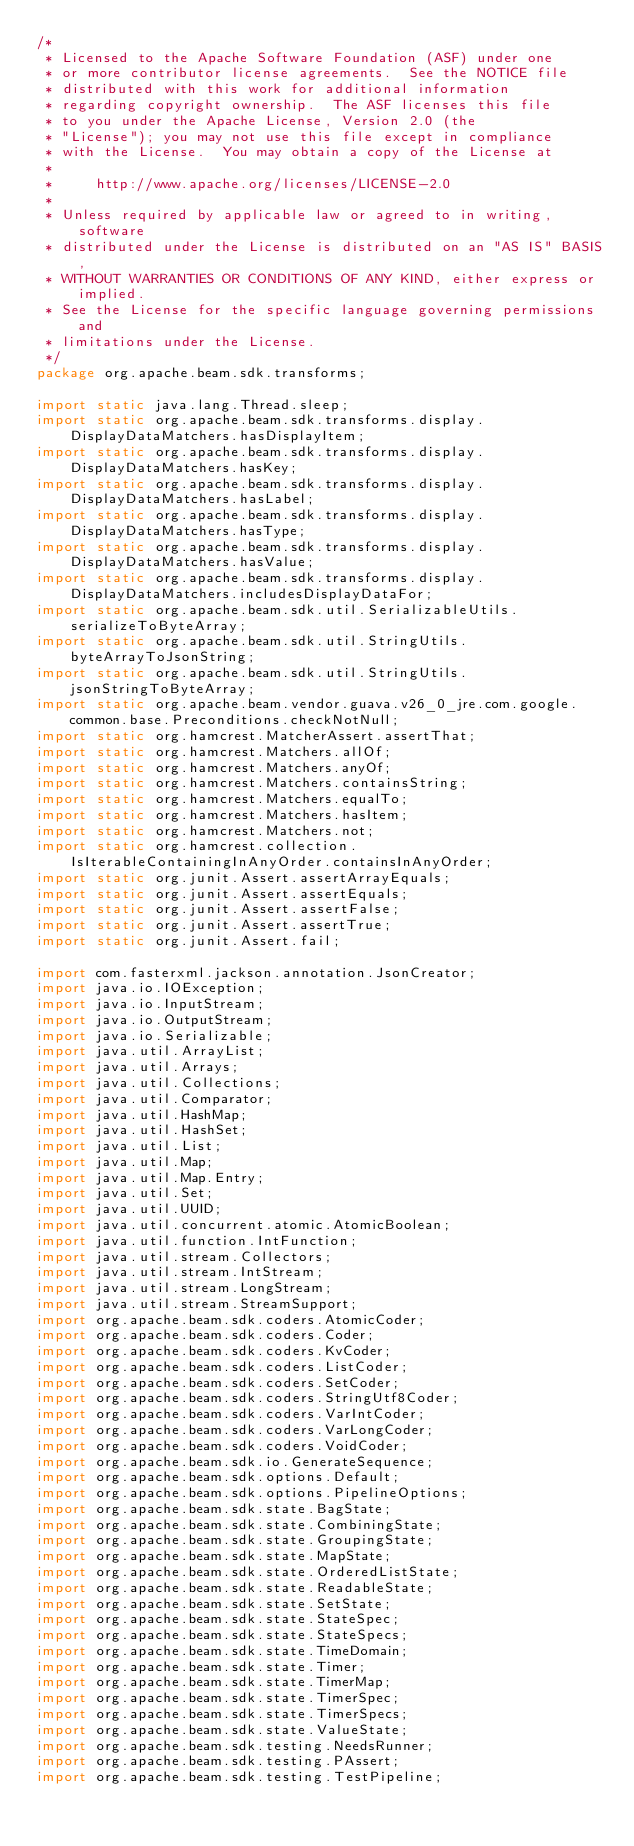Convert code to text. <code><loc_0><loc_0><loc_500><loc_500><_Java_>/*
 * Licensed to the Apache Software Foundation (ASF) under one
 * or more contributor license agreements.  See the NOTICE file
 * distributed with this work for additional information
 * regarding copyright ownership.  The ASF licenses this file
 * to you under the Apache License, Version 2.0 (the
 * "License"); you may not use this file except in compliance
 * with the License.  You may obtain a copy of the License at
 *
 *     http://www.apache.org/licenses/LICENSE-2.0
 *
 * Unless required by applicable law or agreed to in writing, software
 * distributed under the License is distributed on an "AS IS" BASIS,
 * WITHOUT WARRANTIES OR CONDITIONS OF ANY KIND, either express or implied.
 * See the License for the specific language governing permissions and
 * limitations under the License.
 */
package org.apache.beam.sdk.transforms;

import static java.lang.Thread.sleep;
import static org.apache.beam.sdk.transforms.display.DisplayDataMatchers.hasDisplayItem;
import static org.apache.beam.sdk.transforms.display.DisplayDataMatchers.hasKey;
import static org.apache.beam.sdk.transforms.display.DisplayDataMatchers.hasLabel;
import static org.apache.beam.sdk.transforms.display.DisplayDataMatchers.hasType;
import static org.apache.beam.sdk.transforms.display.DisplayDataMatchers.hasValue;
import static org.apache.beam.sdk.transforms.display.DisplayDataMatchers.includesDisplayDataFor;
import static org.apache.beam.sdk.util.SerializableUtils.serializeToByteArray;
import static org.apache.beam.sdk.util.StringUtils.byteArrayToJsonString;
import static org.apache.beam.sdk.util.StringUtils.jsonStringToByteArray;
import static org.apache.beam.vendor.guava.v26_0_jre.com.google.common.base.Preconditions.checkNotNull;
import static org.hamcrest.MatcherAssert.assertThat;
import static org.hamcrest.Matchers.allOf;
import static org.hamcrest.Matchers.anyOf;
import static org.hamcrest.Matchers.containsString;
import static org.hamcrest.Matchers.equalTo;
import static org.hamcrest.Matchers.hasItem;
import static org.hamcrest.Matchers.not;
import static org.hamcrest.collection.IsIterableContainingInAnyOrder.containsInAnyOrder;
import static org.junit.Assert.assertArrayEquals;
import static org.junit.Assert.assertEquals;
import static org.junit.Assert.assertFalse;
import static org.junit.Assert.assertTrue;
import static org.junit.Assert.fail;

import com.fasterxml.jackson.annotation.JsonCreator;
import java.io.IOException;
import java.io.InputStream;
import java.io.OutputStream;
import java.io.Serializable;
import java.util.ArrayList;
import java.util.Arrays;
import java.util.Collections;
import java.util.Comparator;
import java.util.HashMap;
import java.util.HashSet;
import java.util.List;
import java.util.Map;
import java.util.Map.Entry;
import java.util.Set;
import java.util.UUID;
import java.util.concurrent.atomic.AtomicBoolean;
import java.util.function.IntFunction;
import java.util.stream.Collectors;
import java.util.stream.IntStream;
import java.util.stream.LongStream;
import java.util.stream.StreamSupport;
import org.apache.beam.sdk.coders.AtomicCoder;
import org.apache.beam.sdk.coders.Coder;
import org.apache.beam.sdk.coders.KvCoder;
import org.apache.beam.sdk.coders.ListCoder;
import org.apache.beam.sdk.coders.SetCoder;
import org.apache.beam.sdk.coders.StringUtf8Coder;
import org.apache.beam.sdk.coders.VarIntCoder;
import org.apache.beam.sdk.coders.VarLongCoder;
import org.apache.beam.sdk.coders.VoidCoder;
import org.apache.beam.sdk.io.GenerateSequence;
import org.apache.beam.sdk.options.Default;
import org.apache.beam.sdk.options.PipelineOptions;
import org.apache.beam.sdk.state.BagState;
import org.apache.beam.sdk.state.CombiningState;
import org.apache.beam.sdk.state.GroupingState;
import org.apache.beam.sdk.state.MapState;
import org.apache.beam.sdk.state.OrderedListState;
import org.apache.beam.sdk.state.ReadableState;
import org.apache.beam.sdk.state.SetState;
import org.apache.beam.sdk.state.StateSpec;
import org.apache.beam.sdk.state.StateSpecs;
import org.apache.beam.sdk.state.TimeDomain;
import org.apache.beam.sdk.state.Timer;
import org.apache.beam.sdk.state.TimerMap;
import org.apache.beam.sdk.state.TimerSpec;
import org.apache.beam.sdk.state.TimerSpecs;
import org.apache.beam.sdk.state.ValueState;
import org.apache.beam.sdk.testing.NeedsRunner;
import org.apache.beam.sdk.testing.PAssert;
import org.apache.beam.sdk.testing.TestPipeline;</code> 